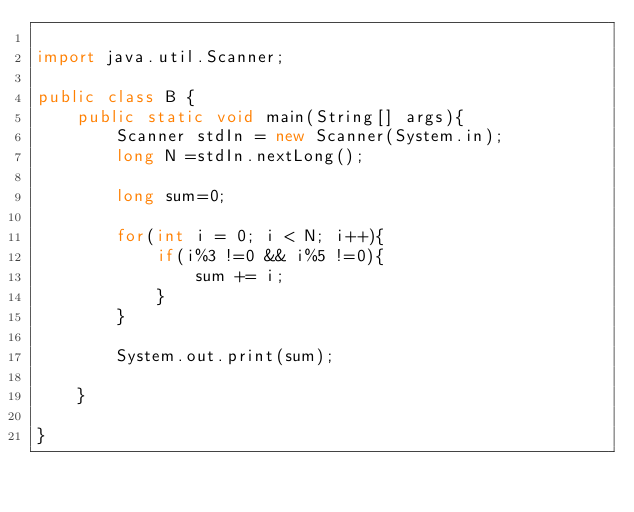<code> <loc_0><loc_0><loc_500><loc_500><_Java_>
import java.util.Scanner;

public class B {
    public static void main(String[] args){
        Scanner stdIn = new Scanner(System.in);
        long N =stdIn.nextLong();

        long sum=0;

        for(int i = 0; i < N; i++){
            if(i%3 !=0 && i%5 !=0){
                sum += i;
            }
        }
        
        System.out.print(sum);

    }

}</code> 